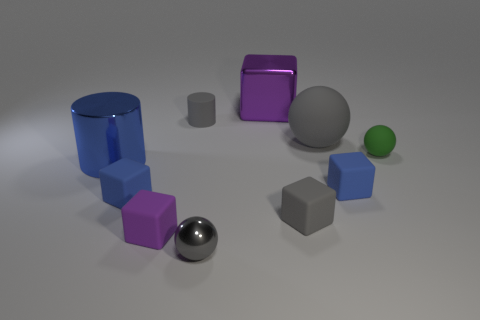Is the gray metal thing the same shape as the large purple metal thing?
Your answer should be compact. No. Are there any other purple things that have the same shape as the tiny purple thing?
Keep it short and to the point. Yes. There is a green thing that is the same size as the gray metallic sphere; what shape is it?
Ensure brevity in your answer.  Sphere. What is the material of the tiny blue block that is in front of the tiny blue block that is on the right side of the ball that is in front of the large metal cylinder?
Provide a short and direct response. Rubber. Does the metallic block have the same size as the green matte thing?
Make the answer very short. No. What material is the large blue cylinder?
Ensure brevity in your answer.  Metal. There is a cylinder that is the same color as the tiny metallic sphere; what is it made of?
Offer a terse response. Rubber. Does the tiny gray matte thing on the right side of the purple metallic block have the same shape as the small green matte thing?
Offer a very short reply. No. What number of things are either small objects or gray cylinders?
Offer a very short reply. 7. Is the blue block to the left of the gray cylinder made of the same material as the large gray sphere?
Ensure brevity in your answer.  Yes. 